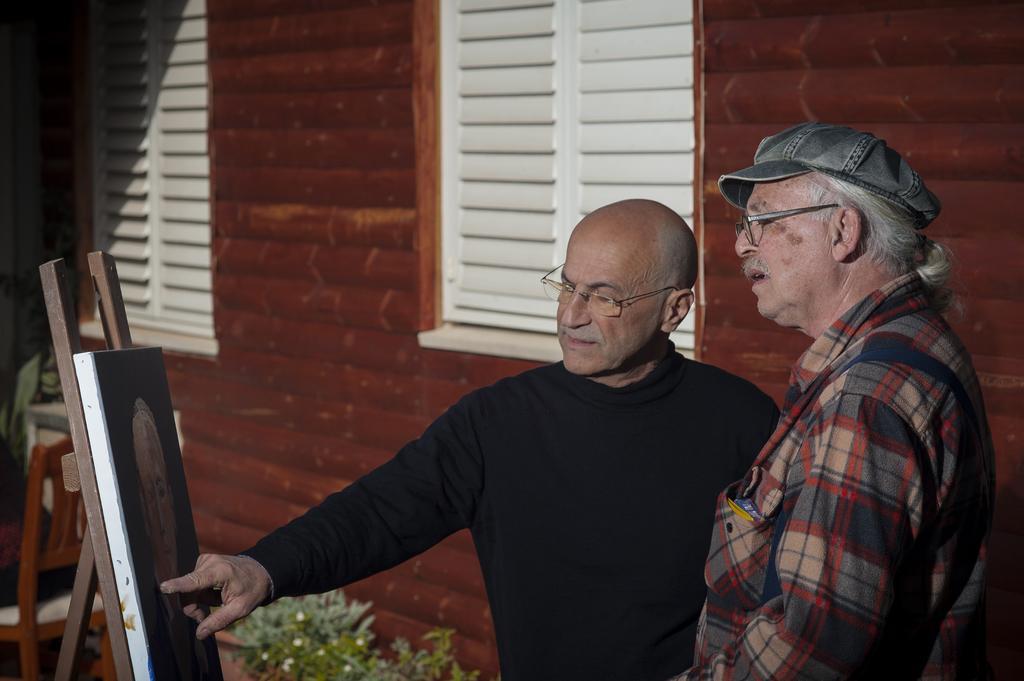In one or two sentences, can you explain what this image depicts? In the image we can see there are two people who are standing and at the back there is a building and the wall is made up of red bricks and the man is pointing towards the portrait. 